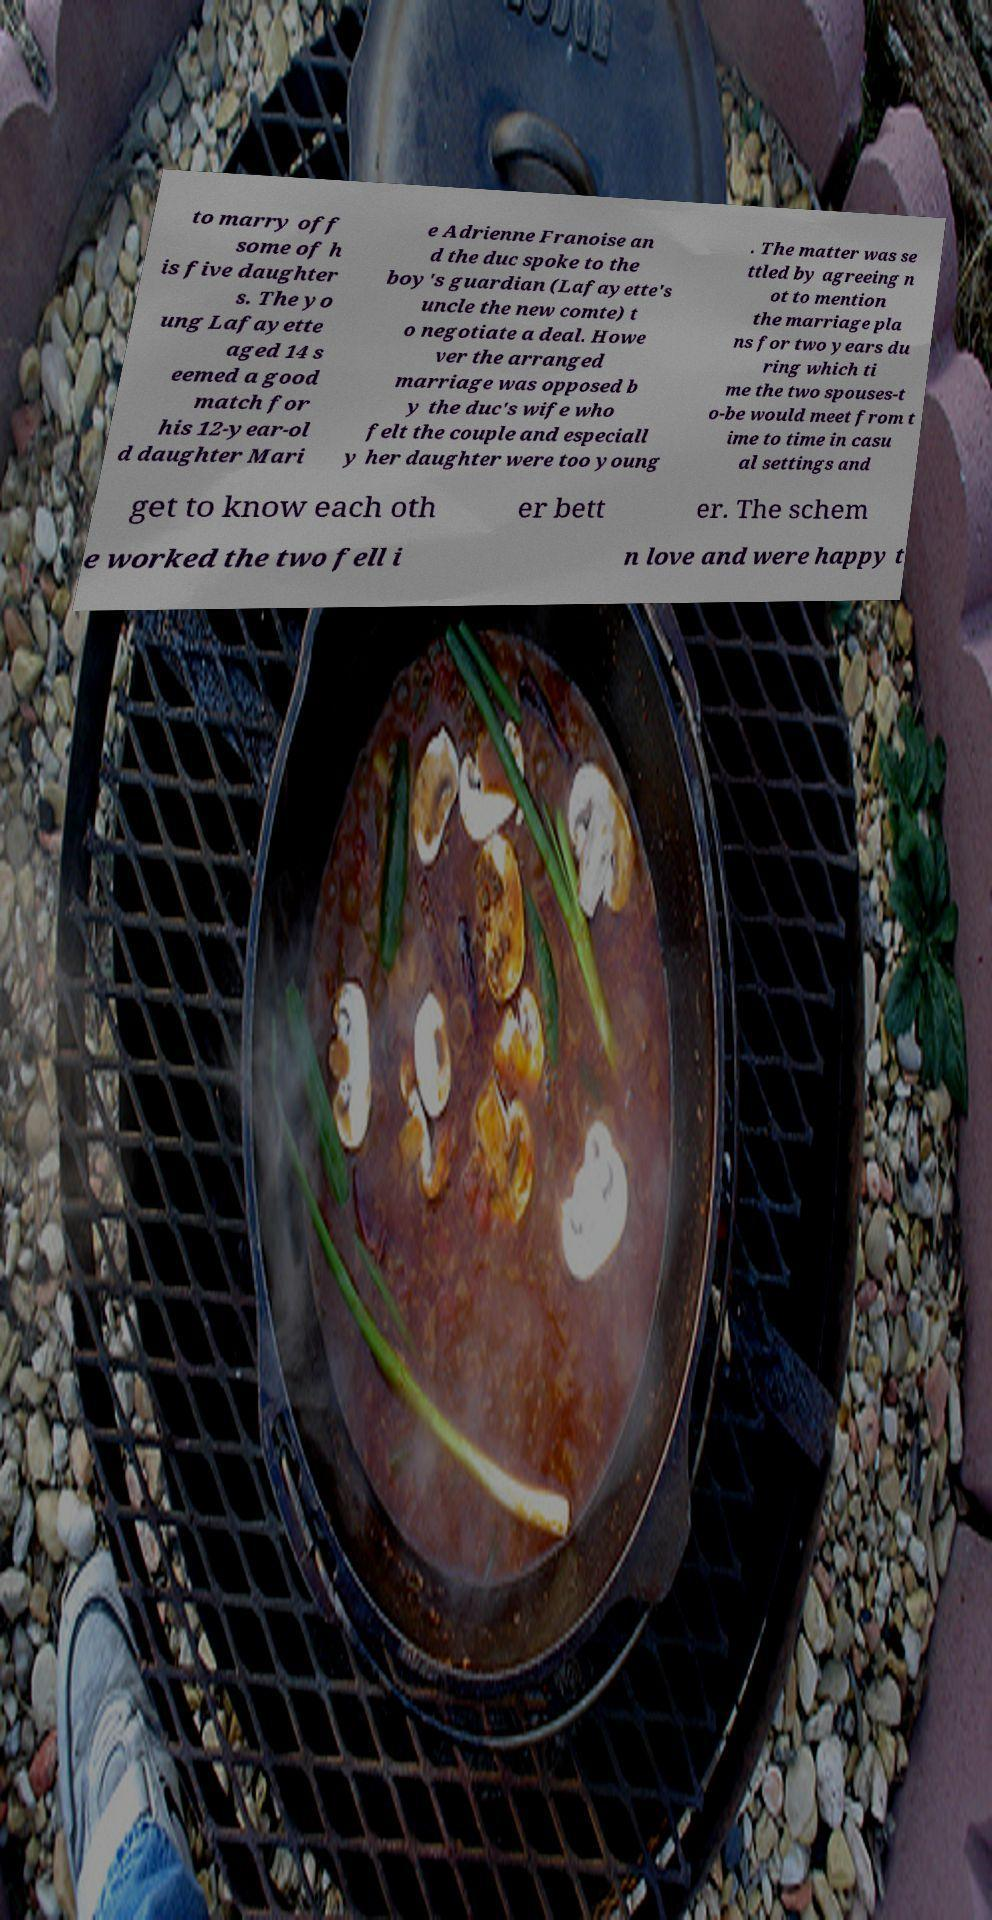Please read and relay the text visible in this image. What does it say? to marry off some of h is five daughter s. The yo ung Lafayette aged 14 s eemed a good match for his 12-year-ol d daughter Mari e Adrienne Franoise an d the duc spoke to the boy's guardian (Lafayette's uncle the new comte) t o negotiate a deal. Howe ver the arranged marriage was opposed b y the duc's wife who felt the couple and especiall y her daughter were too young . The matter was se ttled by agreeing n ot to mention the marriage pla ns for two years du ring which ti me the two spouses-t o-be would meet from t ime to time in casu al settings and get to know each oth er bett er. The schem e worked the two fell i n love and were happy t 